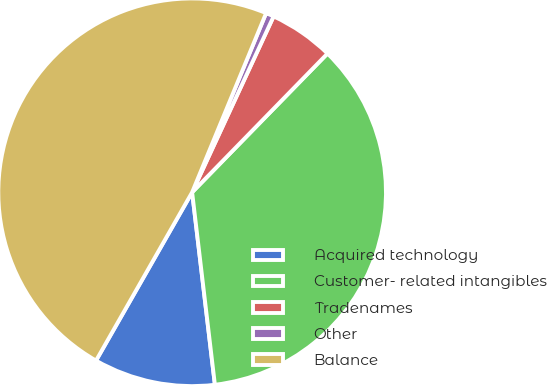<chart> <loc_0><loc_0><loc_500><loc_500><pie_chart><fcel>Acquired technology<fcel>Customer- related intangibles<fcel>Tradenames<fcel>Other<fcel>Balance<nl><fcel>10.13%<fcel>35.82%<fcel>5.4%<fcel>0.67%<fcel>47.97%<nl></chart> 